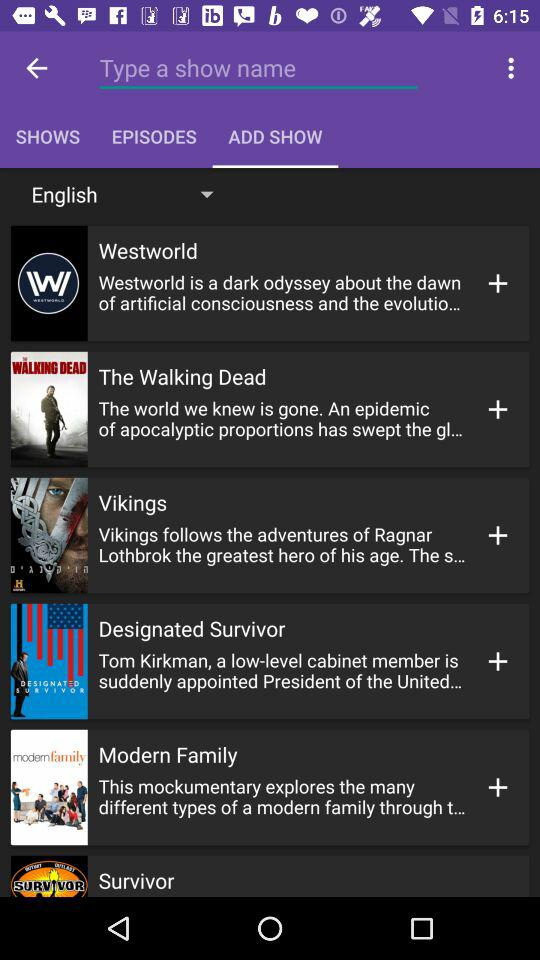What is the language? The language is English. 